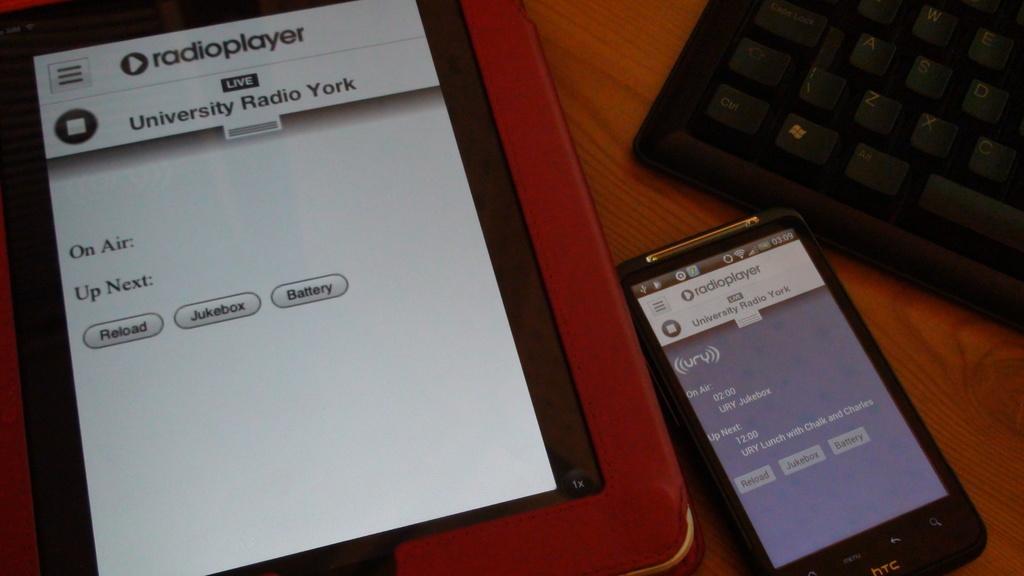What program is on the tablet?
Ensure brevity in your answer.  Radioplayer. What radio station is playing?
Keep it short and to the point. University radio york. 